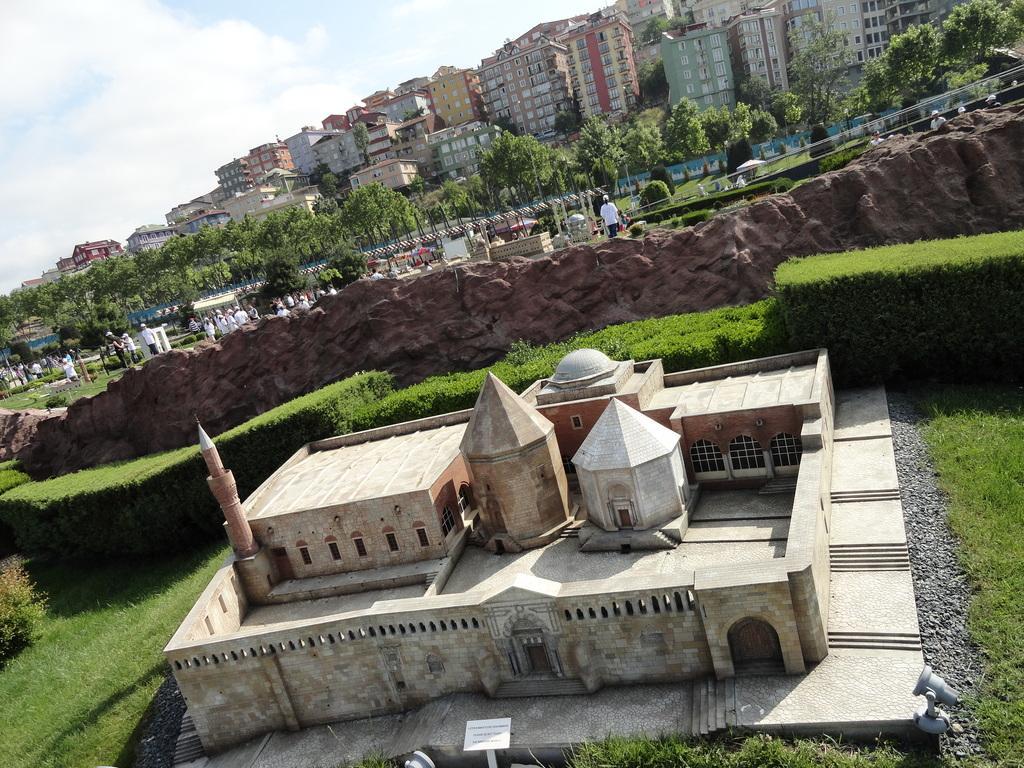How would you summarize this image in a sentence or two? In this image we can see some buildings with windows, there are some plants, trees, people,rocks and grass. In the background we can see the sky. 